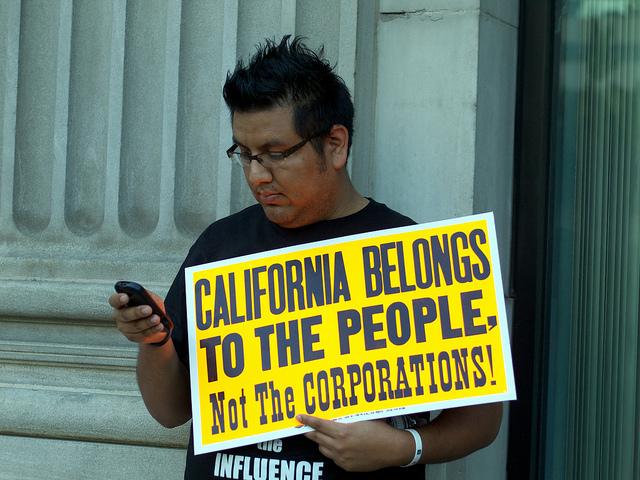Is this person talking to a group?
Short answer required. No. What color is the sign?
Give a very brief answer. Yellow. Does this man look engaged?
Concise answer only. No. 